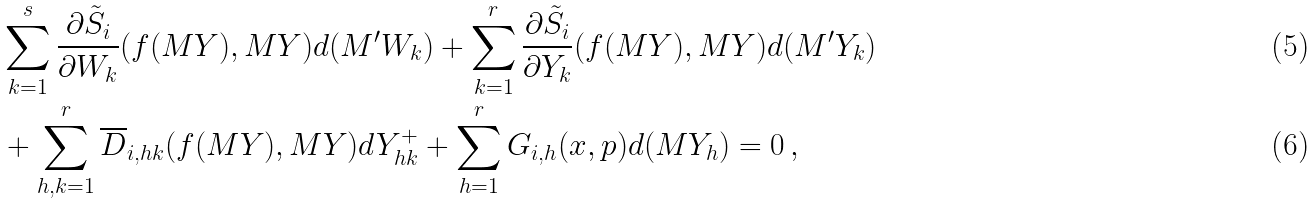<formula> <loc_0><loc_0><loc_500><loc_500>& \sum _ { k = 1 } ^ { s } \frac { \partial \tilde { S } _ { i } } { \partial W _ { k } } ( f ( M Y ) , M Y ) d ( M ^ { \prime } W _ { k } ) + \sum _ { k = 1 } ^ { r } \frac { \partial \tilde { S } _ { i } } { \partial Y _ { k } } ( f ( M Y ) , M Y ) d ( M ^ { \prime } Y _ { k } ) \\ & + \sum _ { h , k = 1 } ^ { r } \overline { D } _ { i , h k } ( f ( M Y ) , M Y ) d Y ^ { + } _ { h k } + \sum _ { h = 1 } ^ { r } G _ { i , h } ( x , p ) d ( M Y _ { h } ) = 0 \, ,</formula> 